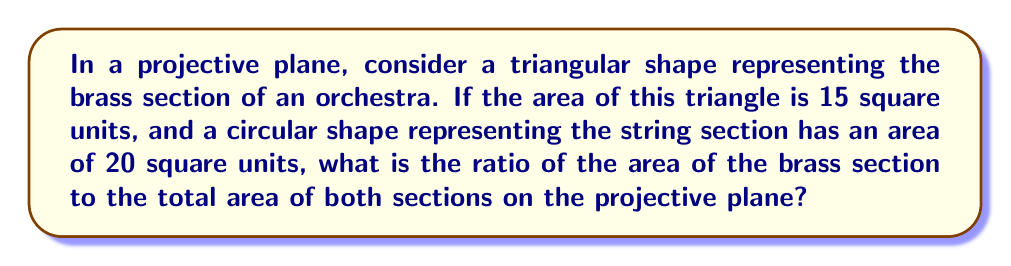Show me your answer to this math problem. Let's approach this step-by-step:

1) In a projective plane, the concept of area is not well-defined in the same way as in Euclidean geometry. However, for this problem, we'll assume we can work with the given areas.

2) We are given:
   - Area of the brass section (triangle): $A_B = 15$ square units
   - Area of the string section (circle): $A_S = 20$ square units

3) The total area is the sum of both sections:
   $A_T = A_B + A_S = 15 + 20 = 35$ square units

4) The ratio of the brass section to the total area is:
   
   $$R = \frac{A_B}{A_T} = \frac{15}{35}$$

5) Simplify the fraction:
   
   $$R = \frac{15}{35} = \frac{3}{7}$$

Thus, the ratio of the area of the brass section to the total area is 3:7.
Answer: $\frac{3}{7}$ 